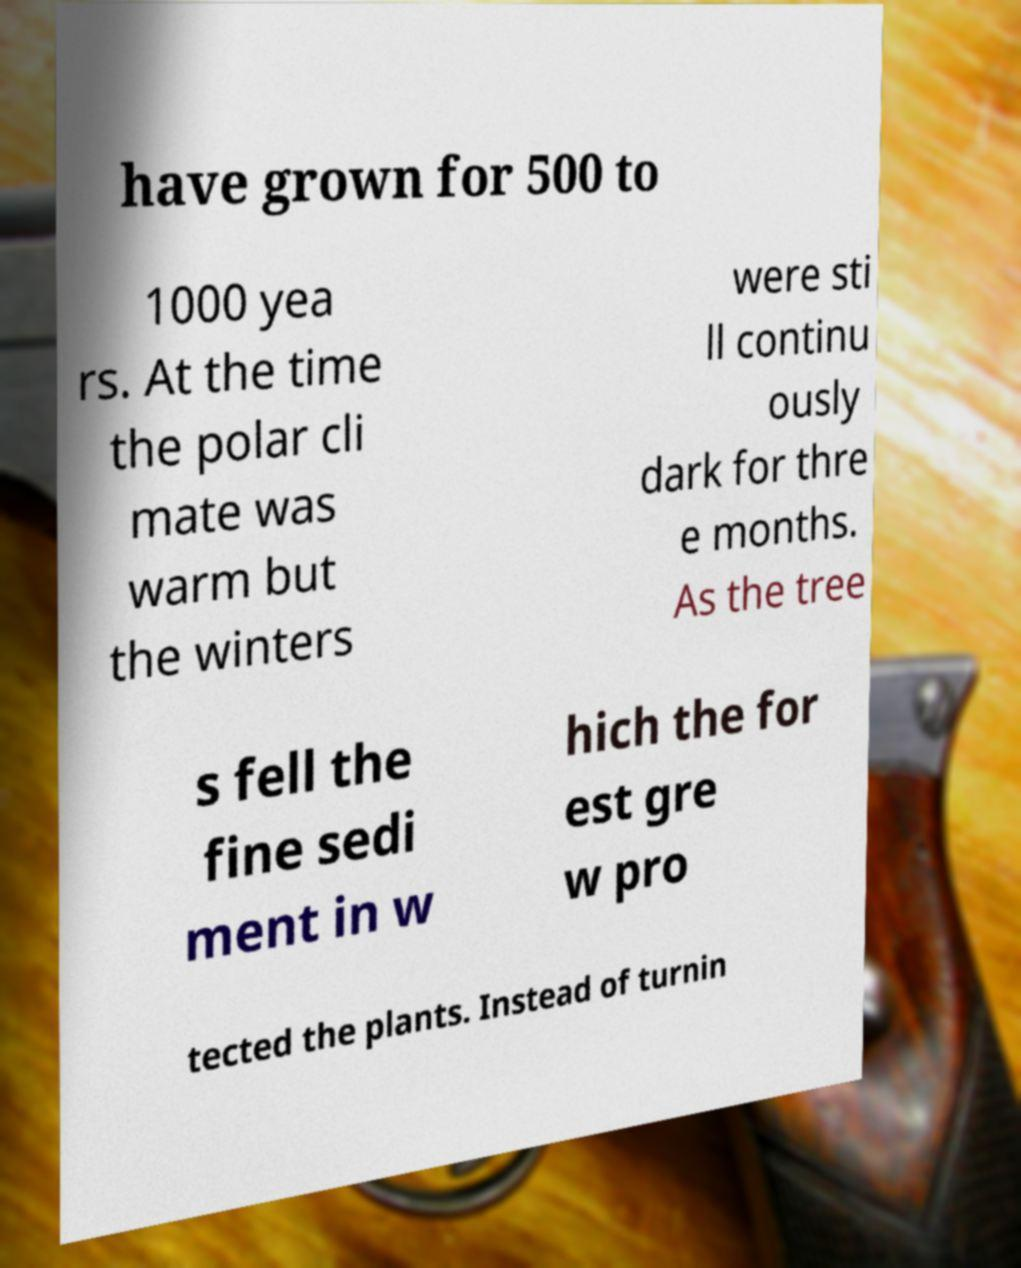Could you assist in decoding the text presented in this image and type it out clearly? have grown for 500 to 1000 yea rs. At the time the polar cli mate was warm but the winters were sti ll continu ously dark for thre e months. As the tree s fell the fine sedi ment in w hich the for est gre w pro tected the plants. Instead of turnin 